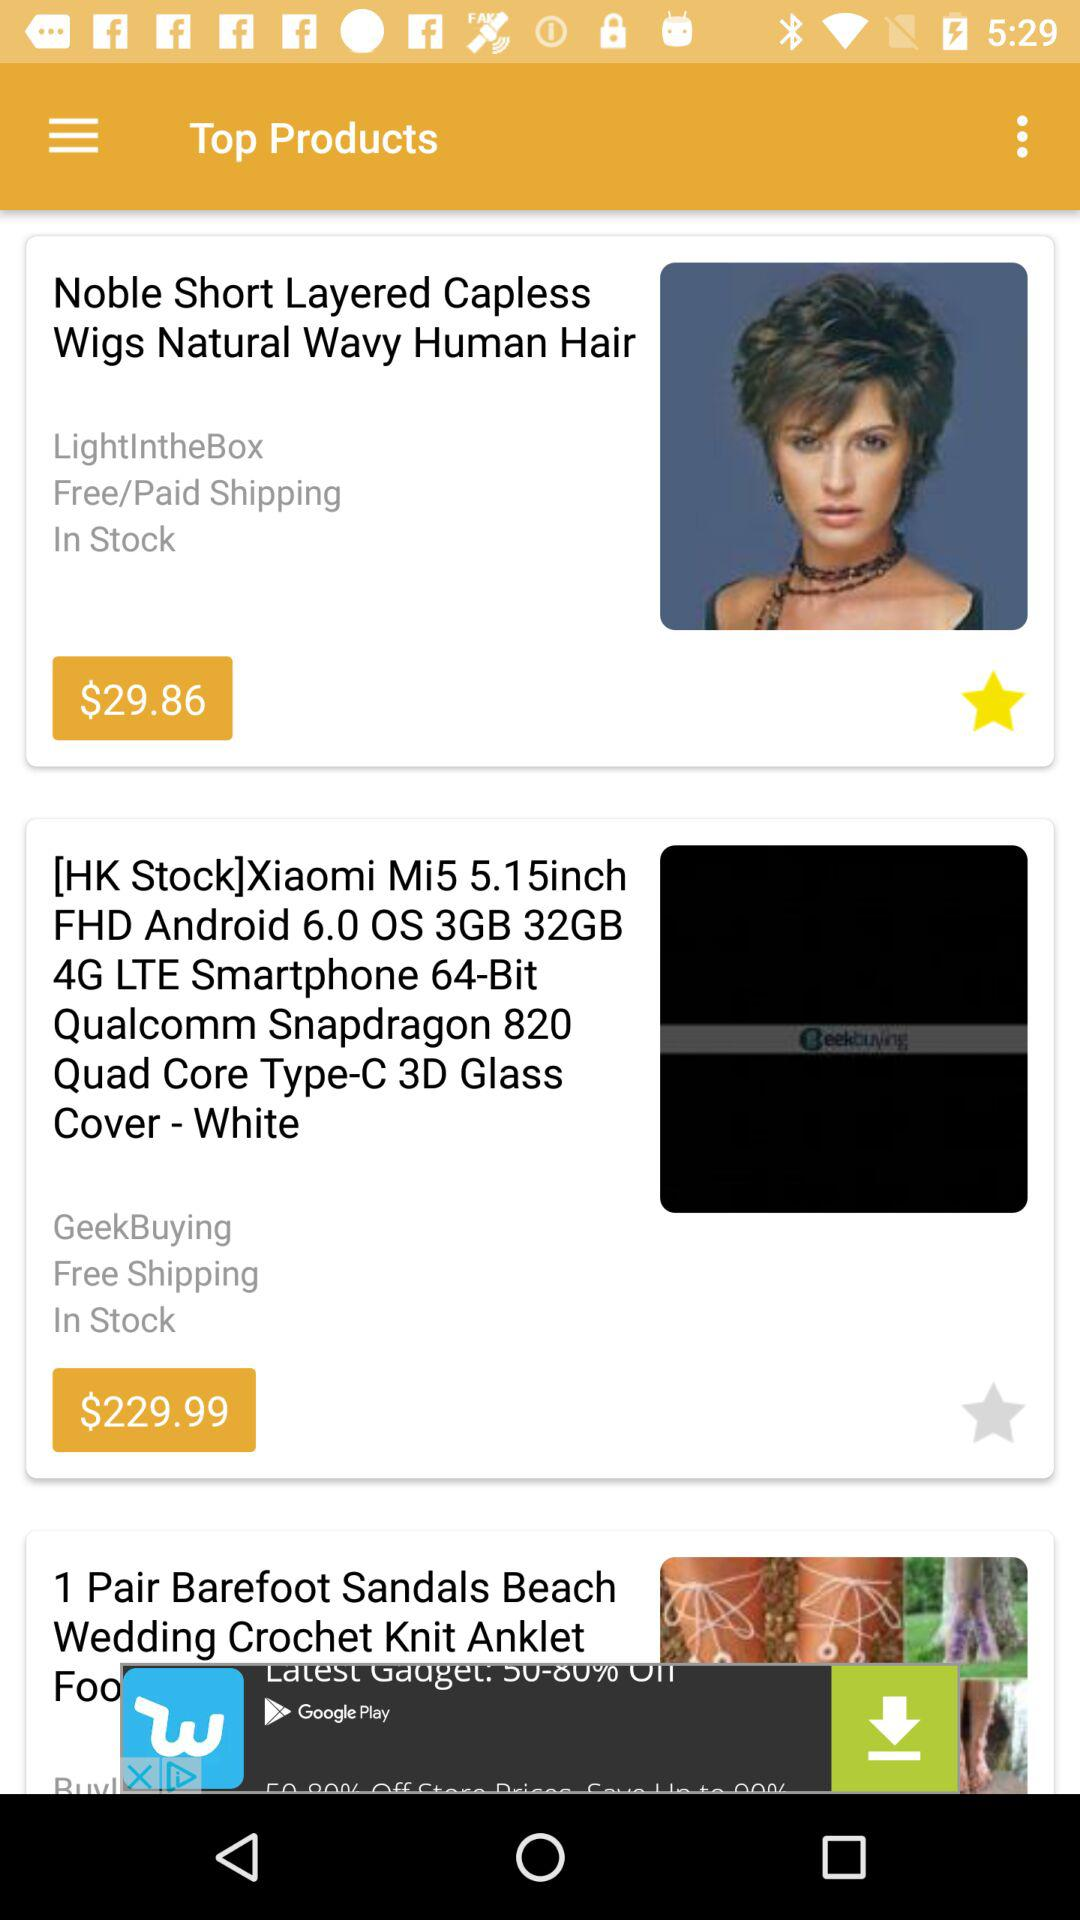What is the price of the "Xiaomi 4G LTE Smartphone"? The price is $229.99. 